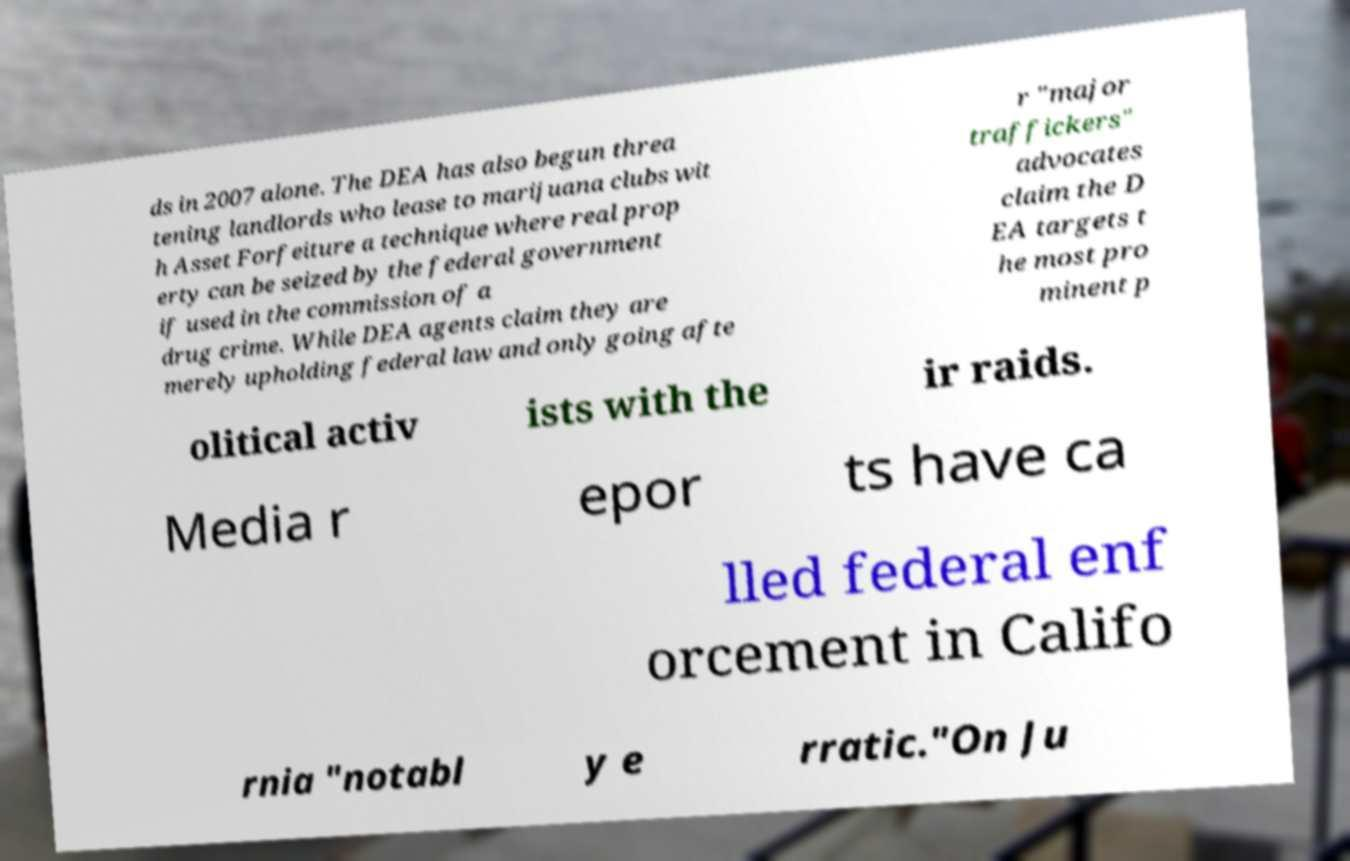Can you read and provide the text displayed in the image?This photo seems to have some interesting text. Can you extract and type it out for me? ds in 2007 alone. The DEA has also begun threa tening landlords who lease to marijuana clubs wit h Asset Forfeiture a technique where real prop erty can be seized by the federal government if used in the commission of a drug crime. While DEA agents claim they are merely upholding federal law and only going afte r "major traffickers" advocates claim the D EA targets t he most pro minent p olitical activ ists with the ir raids. Media r epor ts have ca lled federal enf orcement in Califo rnia "notabl y e rratic."On Ju 